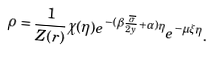Convert formula to latex. <formula><loc_0><loc_0><loc_500><loc_500>\rho = \frac { 1 } { Z ( { r } ) } \chi ( \eta ) e ^ { - ( \beta \frac { \overline { \sigma } } { 2 y } + \alpha ) \eta } e ^ { - \mu \xi \eta } .</formula> 